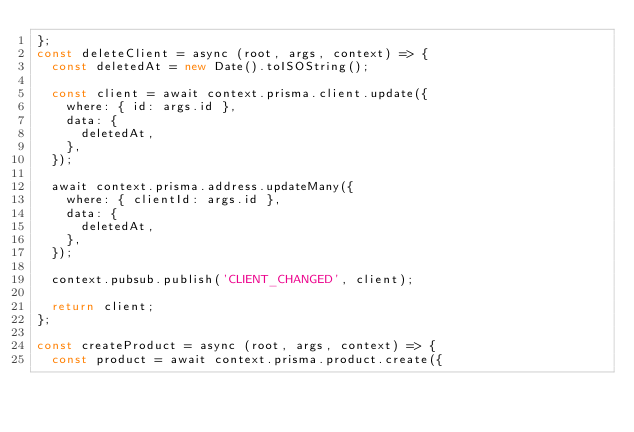Convert code to text. <code><loc_0><loc_0><loc_500><loc_500><_JavaScript_>};
const deleteClient = async (root, args, context) => {
  const deletedAt = new Date().toISOString();

  const client = await context.prisma.client.update({
    where: { id: args.id },
    data: {
      deletedAt,
    },
  });

  await context.prisma.address.updateMany({
    where: { clientId: args.id },
    data: {
      deletedAt,
    },
  });

  context.pubsub.publish('CLIENT_CHANGED', client);

  return client;
};

const createProduct = async (root, args, context) => {
  const product = await context.prisma.product.create({</code> 